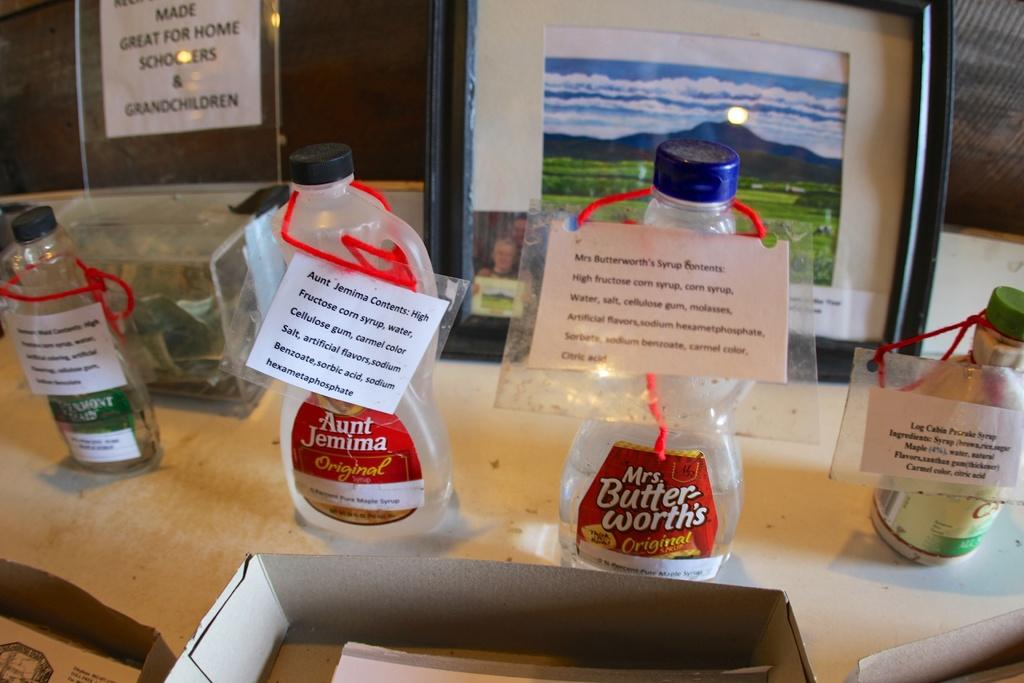<image>
Summarize the visual content of the image. Mrs butterworths syrup bottles sit on display with the ingredients listed on a white paper 